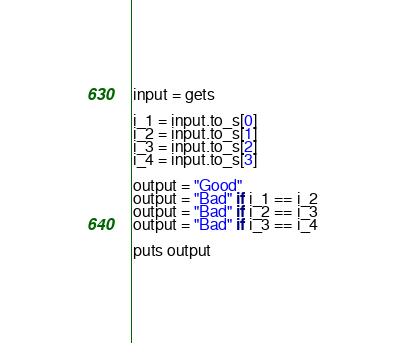Convert code to text. <code><loc_0><loc_0><loc_500><loc_500><_Ruby_>input = gets

i_1 = input.to_s[0]
i_2 = input.to_s[1]
i_3 = input.to_s[2]
i_4 = input.to_s[3]

output = "Good"
output = "Bad" if i_1 == i_2
output = "Bad" if i_2 == i_3
output = "Bad" if i_3 == i_4

puts output
</code> 